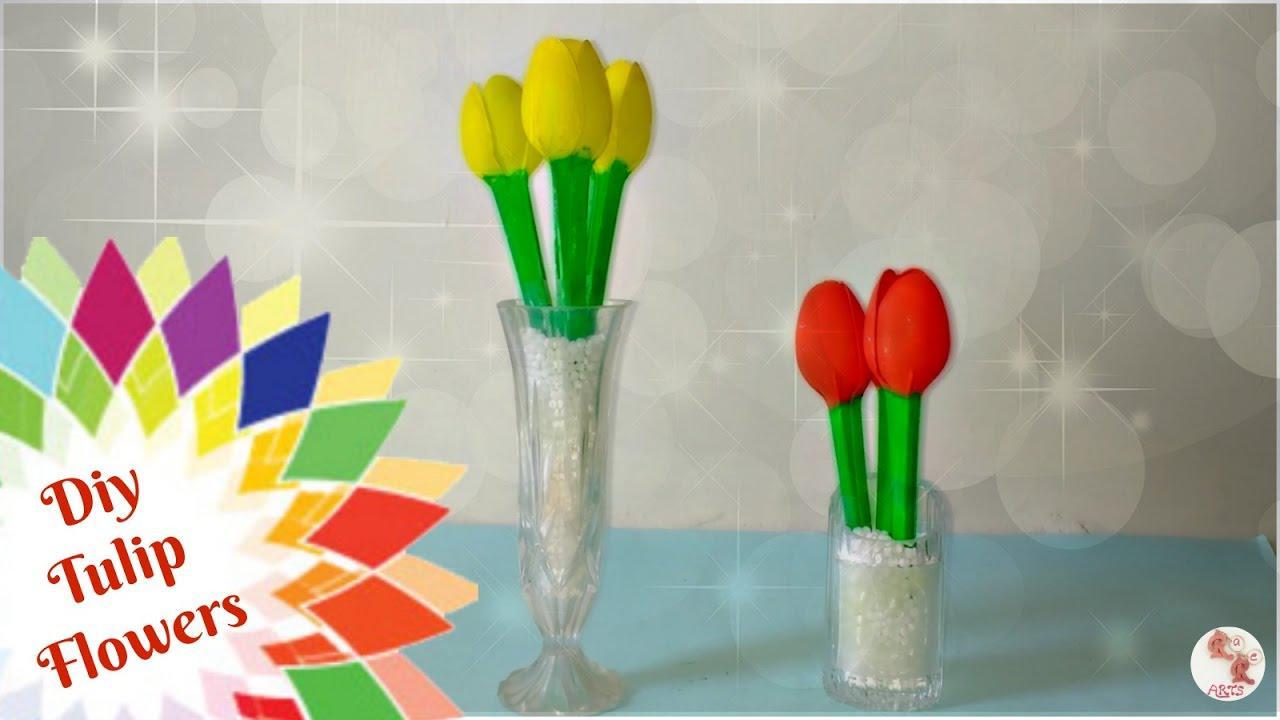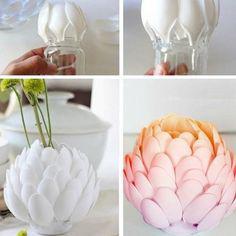The first image is the image on the left, the second image is the image on the right. For the images displayed, is the sentence "There is a plant in a blue vase." factually correct? Answer yes or no. No. 